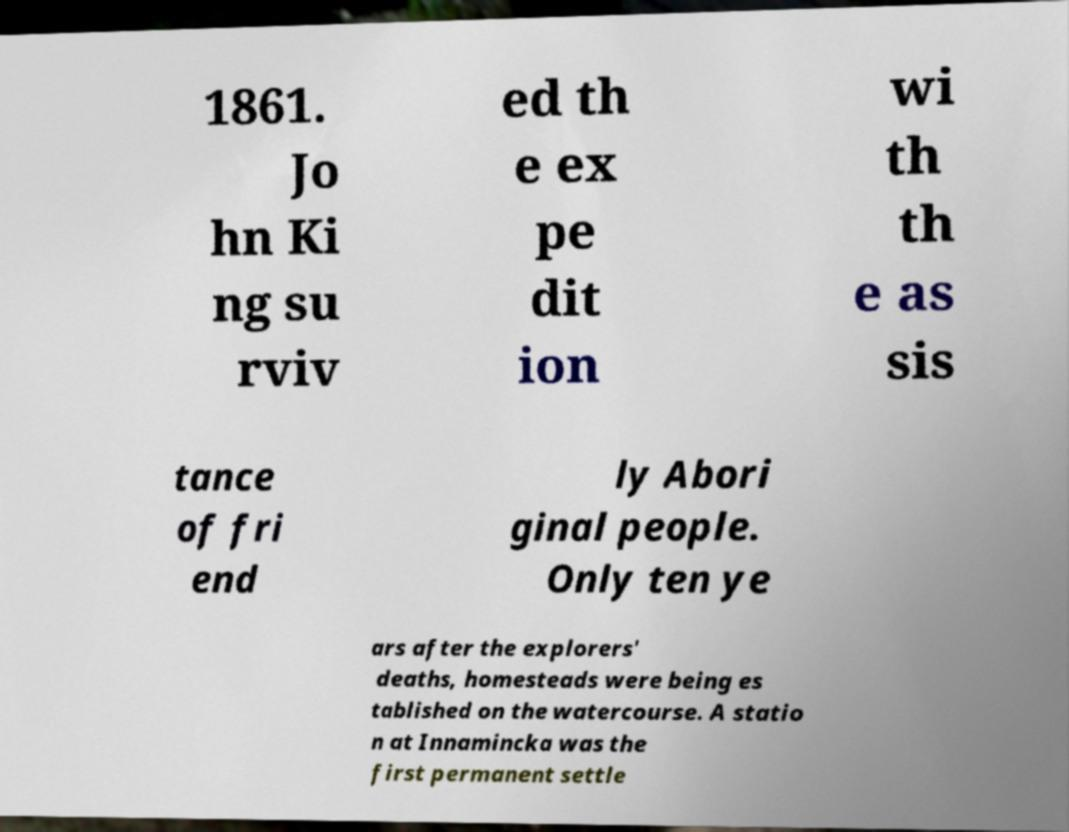Please identify and transcribe the text found in this image. 1861. Jo hn Ki ng su rviv ed th e ex pe dit ion wi th th e as sis tance of fri end ly Abori ginal people. Only ten ye ars after the explorers' deaths, homesteads were being es tablished on the watercourse. A statio n at Innamincka was the first permanent settle 